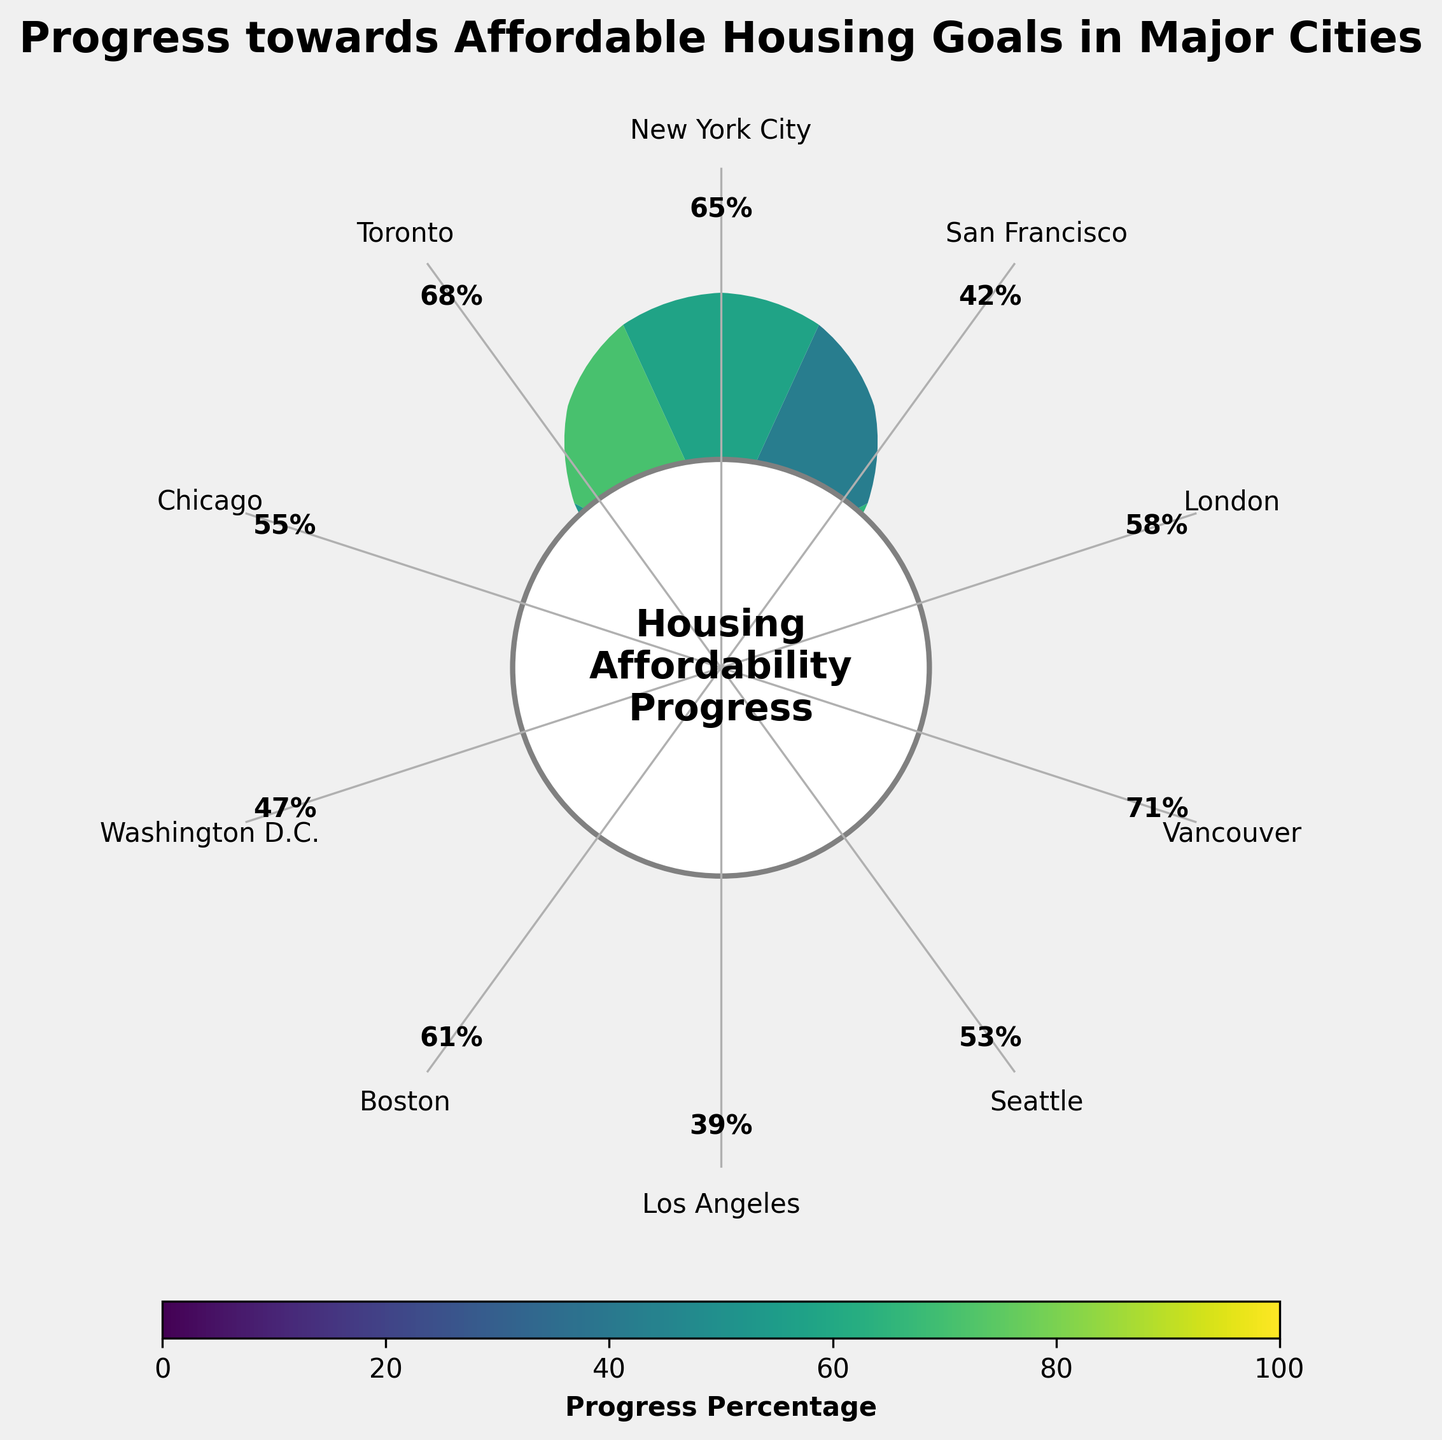What is the title of the figure? The title of the figure is displayed at the top of the plot. It gives an overview of what the image is about. The title is "Progress towards Affordable Housing Goals in Major Cities".
Answer: Progress towards Affordable Housing Goals in Major Cities Which city has the highest progress percentage? The progress percentages are listed next to each city on the figure. The city with the highest percentage is Vancouver with 71%.
Answer: Vancouver Which city has the lowest progress percentage? The progress percentages are listed next to each city on the figure. The city with the lowest percentage is Los Angeles with 39%.
Answer: Los Angeles How many cities have a progress percentage above 60%? By observing the percentages listed next to each city on the figure, count the number of cities with percentages above 60%. The cities are New York City (65%), Vancouver (71%), Boston (61%), and Toronto (68%). This gives us 4 cities.
Answer: 4 What is the average progress percentage across all listed cities? To compute the average, sum all the progress percentages and divide by the number of cities: (65 + 42 + 58 + 71 + 53 + 39 + 61 + 47 + 55 + 68) / 10 = 55.9%.
Answer: 55.9% Which city has a progress percentage closest to the median value of all cities? First, list all the progress percentages and find the median value. The sorted list is [39, 42, 47, 53, 55, 58, 61, 65, 68, 71], and the median is the average of 55 and 58, giving 56.5%. The city with the progress nearest to 56.5% is Chicago with 55%.
Answer: Chicago Compare the progress of Boston to that of London. Which city has made more progress towards its affordable housing goals? The progress percentages for Boston and London are 61% and 58% respectively. Boston has a higher percentage than London.
Answer: Boston How does the progress percentage of Washington D.C. compare to the average progress percentage of all cities? The average progress percentage is 55.9%. Washington D.C. has a progress percentage of 47%. Since 47% is less than 55.9%, Washington D.C. is below the average progress percentage.
Answer: Below average Based on the color gradient, which city shows a distinct shift in color shade indicating lower progress? The color gradient changes with progress percentage, with darker shades indicating lower progress. Los Angeles at 39% shows a distinct darker shade indicating lower progress.
Answer: Los Angeles Combining the information from the figure, which three cities would you prioritize funding for housing affordability projects given their progress percentages? To determine the cities that may need more support, look for the lowest progress percentages. These cities are Los Angeles (39%), San Francisco (42%), and Washington D.C. (47%).
Answer: Los Angeles, San Francisco, Washington D.C 